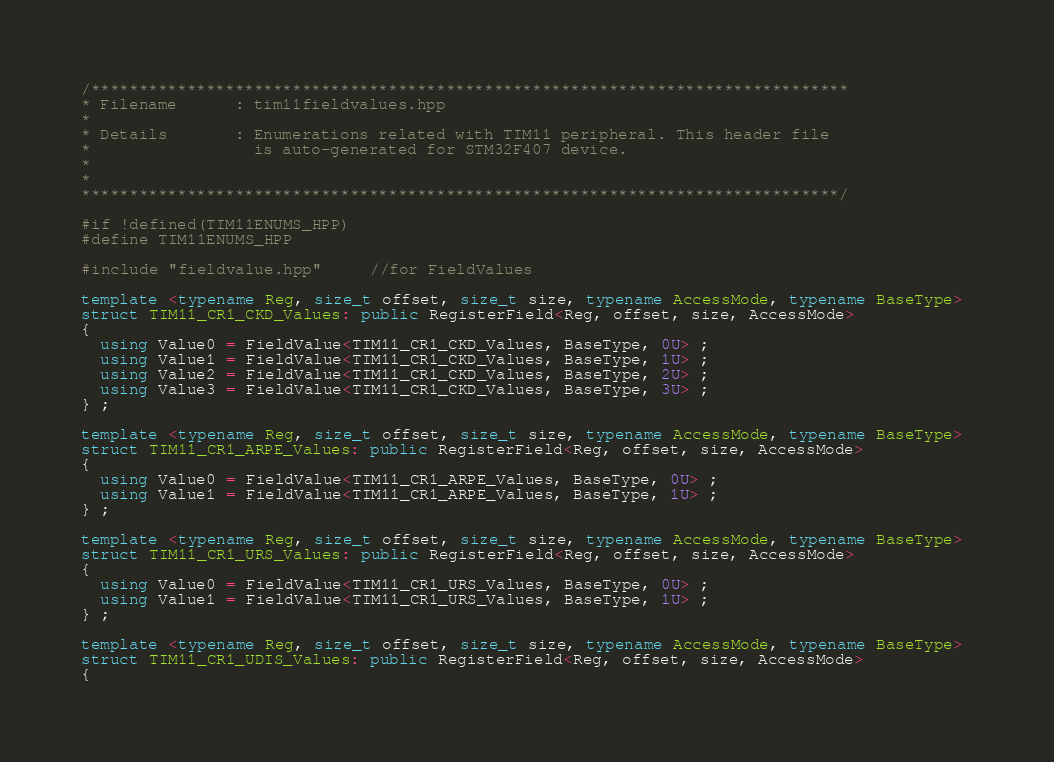<code> <loc_0><loc_0><loc_500><loc_500><_C++_>/*******************************************************************************
* Filename      : tim11fieldvalues.hpp
*
* Details       : Enumerations related with TIM11 peripheral. This header file
*                 is auto-generated for STM32F407 device.
*
*
*******************************************************************************/

#if !defined(TIM11ENUMS_HPP)
#define TIM11ENUMS_HPP

#include "fieldvalue.hpp"     //for FieldValues 

template <typename Reg, size_t offset, size_t size, typename AccessMode, typename BaseType> 
struct TIM11_CR1_CKD_Values: public RegisterField<Reg, offset, size, AccessMode> 
{
  using Value0 = FieldValue<TIM11_CR1_CKD_Values, BaseType, 0U> ;
  using Value1 = FieldValue<TIM11_CR1_CKD_Values, BaseType, 1U> ;
  using Value2 = FieldValue<TIM11_CR1_CKD_Values, BaseType, 2U> ;
  using Value3 = FieldValue<TIM11_CR1_CKD_Values, BaseType, 3U> ;
} ;

template <typename Reg, size_t offset, size_t size, typename AccessMode, typename BaseType> 
struct TIM11_CR1_ARPE_Values: public RegisterField<Reg, offset, size, AccessMode> 
{
  using Value0 = FieldValue<TIM11_CR1_ARPE_Values, BaseType, 0U> ;
  using Value1 = FieldValue<TIM11_CR1_ARPE_Values, BaseType, 1U> ;
} ;

template <typename Reg, size_t offset, size_t size, typename AccessMode, typename BaseType> 
struct TIM11_CR1_URS_Values: public RegisterField<Reg, offset, size, AccessMode> 
{
  using Value0 = FieldValue<TIM11_CR1_URS_Values, BaseType, 0U> ;
  using Value1 = FieldValue<TIM11_CR1_URS_Values, BaseType, 1U> ;
} ;

template <typename Reg, size_t offset, size_t size, typename AccessMode, typename BaseType> 
struct TIM11_CR1_UDIS_Values: public RegisterField<Reg, offset, size, AccessMode> 
{</code> 